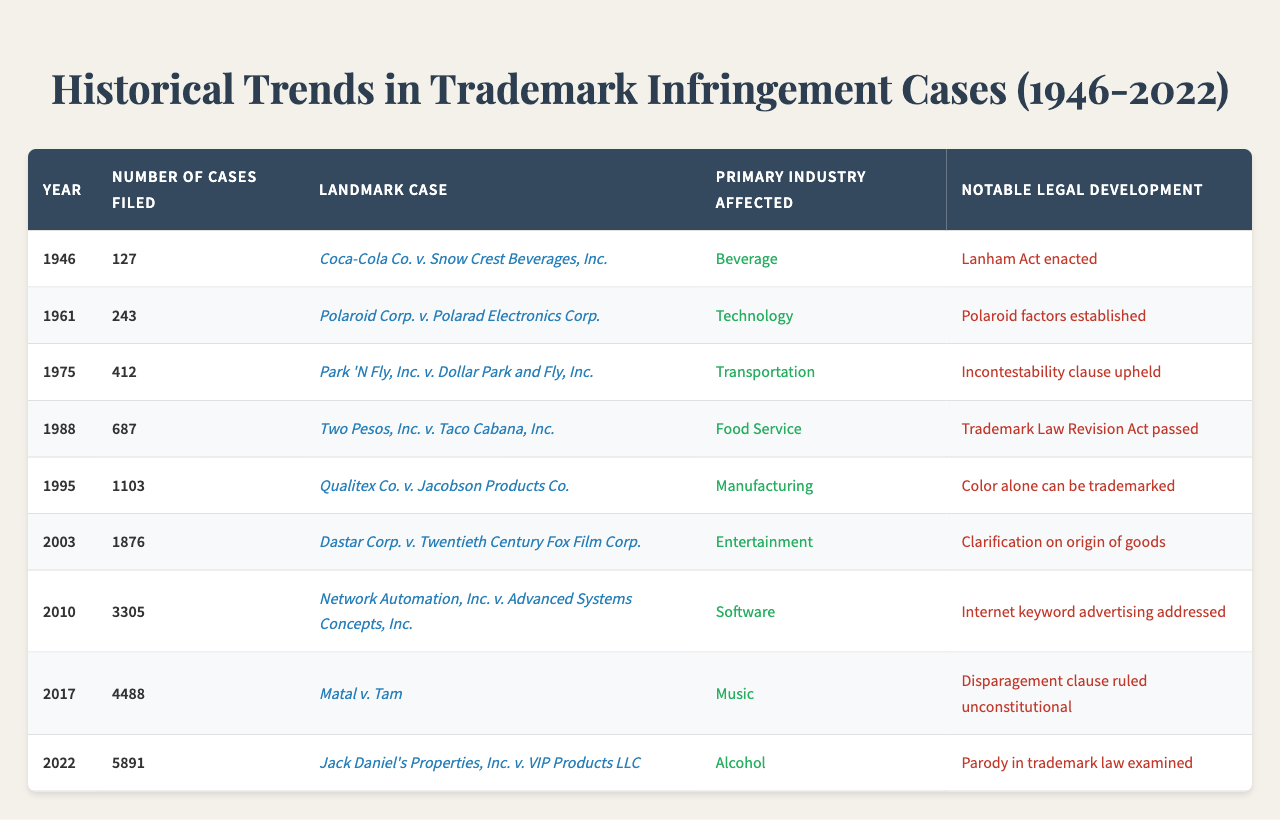What year had the highest number of trademark infringement cases filed? By reviewing the "Number of Cases Filed" column, the year with the highest count is 2022 with 5891 cases.
Answer: 2022 What landmark case was associated with the year 1988? The table states that the landmark case for 1988 is "Two Pesos, Inc. v. Taco Cabana, Inc."
Answer: Two Pesos, Inc. v. Taco Cabana, Inc In which primary industry were the most cases filed in 2010? Referring to the table, the primary industry for 2010 with the most cases filed (3305) is "Software."
Answer: Software What notable legal development occurred in 1995? According to the table, the notable development in 1995 was that "Color alone can be trademarked."
Answer: Color alone can be trademarked How many trademark infringement cases were filed in the years 1975 and 1988 combined? Summing the cases from the years 1975 (412) and 1988 (687), we get 412 + 687 = 1099.
Answer: 1099 Is it true that the number of cases filed increased every decade from 1946 to 2022? Evaluating the data table, we observe that the number of cases increased overall, especially from 1988 onwards. Therefore, the statement is true.
Answer: Yes What was the average number of cases filed between 1961 and 1995? To find the average, sum the cases filed from 1961 (243), 1975 (412), 1988 (687), and 1995 (1103), which totals 2445. Dividing that by the 4 years yields an average of 2445/4 = 611.25.
Answer: 611.25 Which industry experienced a notable development related to "Internet keyword advertising" and in what year? The table specifies that the notable development related to "Internet keyword advertising" was in the year 2010, with the primary industry being "Software."
Answer: Software, 2010 From which year to which year did the number of cases filed grow from 412 to 3305? The number of cases grew from 412 in 1975 to 3305 in 2010. This indicates the growth occurred between these years.
Answer: 1975 to 2010 Which case of 2003 clarified the origin of goods in trademark law? The case listed for 2003 that clarified the origin of goods is "Dastar Corp. v. Twentieth Century Fox Film Corp."
Answer: Dastar Corp. v. Twentieth Century Fox Film Corp 